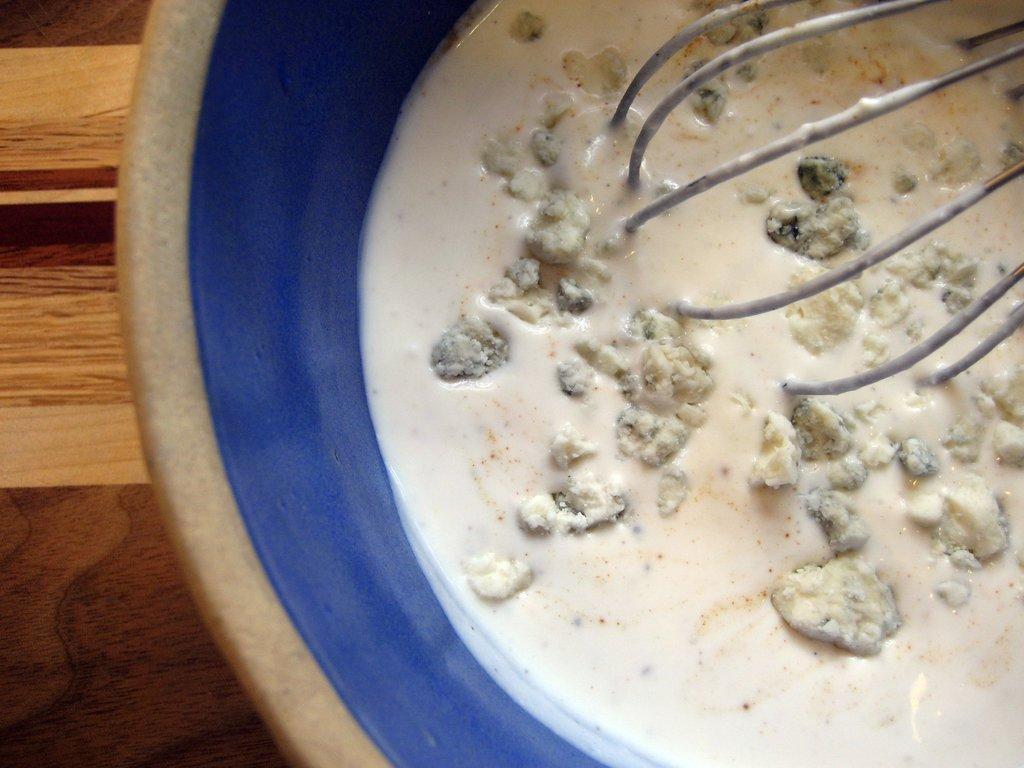Please provide a concise description of this image. In the image there is white liquid with dough in a beaker with a mixing tool on a wooden table. 